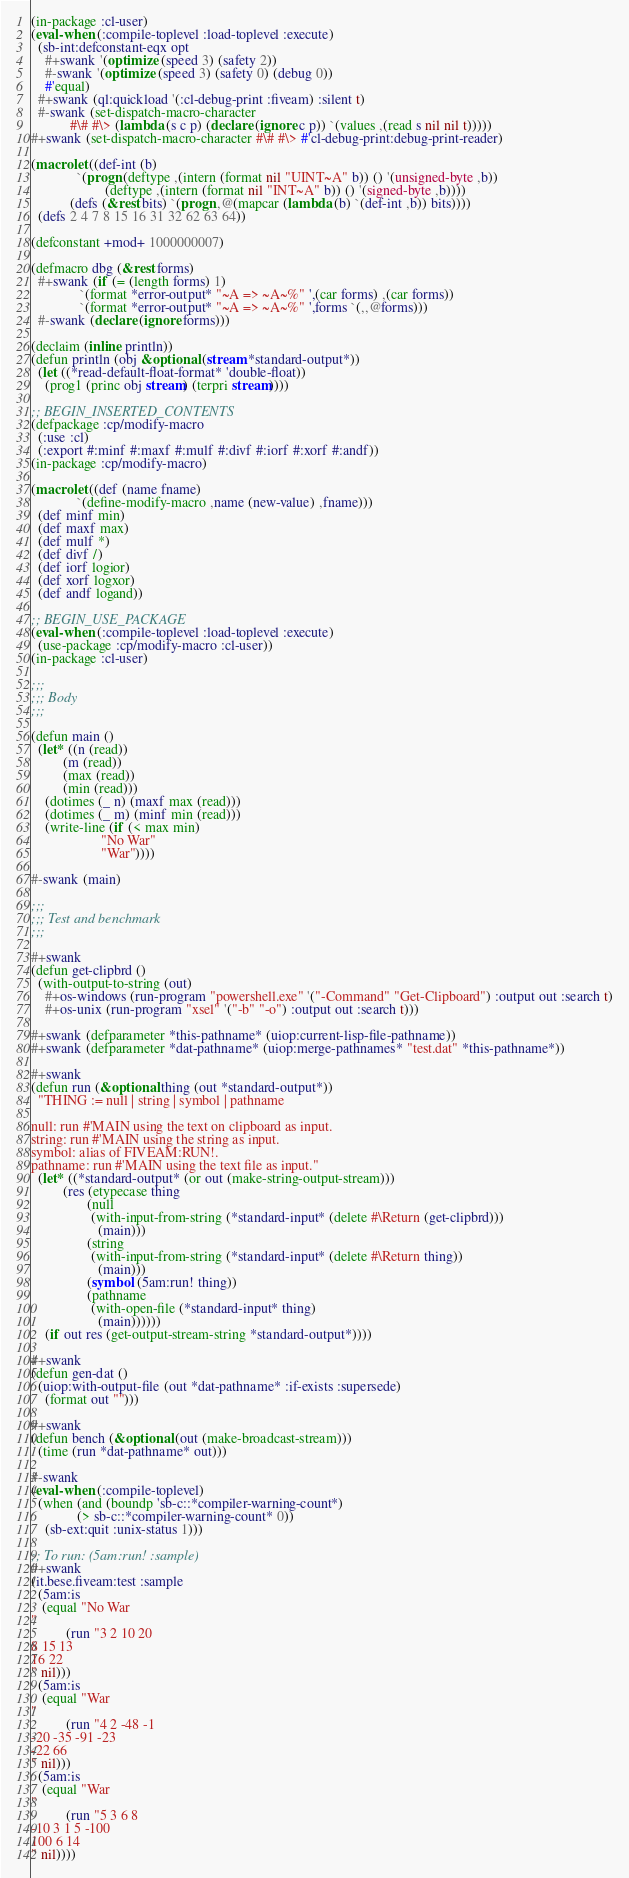<code> <loc_0><loc_0><loc_500><loc_500><_Lisp_>(in-package :cl-user)
(eval-when (:compile-toplevel :load-toplevel :execute)
  (sb-int:defconstant-eqx opt
    #+swank '(optimize (speed 3) (safety 2))
    #-swank '(optimize (speed 3) (safety 0) (debug 0))
    #'equal)
  #+swank (ql:quickload '(:cl-debug-print :fiveam) :silent t)
  #-swank (set-dispatch-macro-character
           #\# #\> (lambda (s c p) (declare (ignore c p)) `(values ,(read s nil nil t)))))
#+swank (set-dispatch-macro-character #\# #\> #'cl-debug-print:debug-print-reader)

(macrolet ((def-int (b)
             `(progn (deftype ,(intern (format nil "UINT~A" b)) () '(unsigned-byte ,b))
                     (deftype ,(intern (format nil "INT~A" b)) () '(signed-byte ,b))))
           (defs (&rest bits) `(progn ,@(mapcar (lambda (b) `(def-int ,b)) bits))))
  (defs 2 4 7 8 15 16 31 32 62 63 64))

(defconstant +mod+ 1000000007)

(defmacro dbg (&rest forms)
  #+swank (if (= (length forms) 1)
              `(format *error-output* "~A => ~A~%" ',(car forms) ,(car forms))
              `(format *error-output* "~A => ~A~%" ',forms `(,,@forms)))
  #-swank (declare (ignore forms)))

(declaim (inline println))
(defun println (obj &optional (stream *standard-output*))
  (let ((*read-default-float-format* 'double-float))
    (prog1 (princ obj stream) (terpri stream))))

;; BEGIN_INSERTED_CONTENTS
(defpackage :cp/modify-macro
  (:use :cl)
  (:export #:minf #:maxf #:mulf #:divf #:iorf #:xorf #:andf))
(in-package :cp/modify-macro)

(macrolet ((def (name fname)
             `(define-modify-macro ,name (new-value) ,fname)))
  (def minf min)
  (def maxf max)
  (def mulf *)
  (def divf /)
  (def iorf logior)
  (def xorf logxor)
  (def andf logand))

;; BEGIN_USE_PACKAGE
(eval-when (:compile-toplevel :load-toplevel :execute)
  (use-package :cp/modify-macro :cl-user))
(in-package :cl-user)

;;;
;;; Body
;;;

(defun main ()
  (let* ((n (read))
         (m (read))
         (max (read))
         (min (read)))
    (dotimes (_ n) (maxf max (read)))
    (dotimes (_ m) (minf min (read)))
    (write-line (if (< max min)
                    "No War"
                    "War"))))

#-swank (main)

;;;
;;; Test and benchmark
;;;

#+swank
(defun get-clipbrd ()
  (with-output-to-string (out)
    #+os-windows (run-program "powershell.exe" '("-Command" "Get-Clipboard") :output out :search t)
    #+os-unix (run-program "xsel" '("-b" "-o") :output out :search t)))

#+swank (defparameter *this-pathname* (uiop:current-lisp-file-pathname))
#+swank (defparameter *dat-pathname* (uiop:merge-pathnames* "test.dat" *this-pathname*))

#+swank
(defun run (&optional thing (out *standard-output*))
  "THING := null | string | symbol | pathname

null: run #'MAIN using the text on clipboard as input.
string: run #'MAIN using the string as input.
symbol: alias of FIVEAM:RUN!.
pathname: run #'MAIN using the text file as input."
  (let* ((*standard-output* (or out (make-string-output-stream)))
         (res (etypecase thing
                (null
                 (with-input-from-string (*standard-input* (delete #\Return (get-clipbrd)))
                   (main)))
                (string
                 (with-input-from-string (*standard-input* (delete #\Return thing))
                   (main)))
                (symbol (5am:run! thing))
                (pathname
                 (with-open-file (*standard-input* thing)
                   (main))))))
    (if out res (get-output-stream-string *standard-output*))))

#+swank
(defun gen-dat ()
  (uiop:with-output-file (out *dat-pathname* :if-exists :supersede)
    (format out "")))

#+swank
(defun bench (&optional (out (make-broadcast-stream)))
  (time (run *dat-pathname* out)))

#-swank
(eval-when (:compile-toplevel)
  (when (and (boundp 'sb-c::*compiler-warning-count*)
             (> sb-c::*compiler-warning-count* 0))
    (sb-ext:quit :unix-status 1)))

;; To run: (5am:run! :sample)
#+swank
(it.bese.fiveam:test :sample
  (5am:is
   (equal "No War
"
          (run "3 2 10 20
8 15 13
16 22
" nil)))
  (5am:is
   (equal "War
"
          (run "4 2 -48 -1
-20 -35 -91 -23
-22 66
" nil)))
  (5am:is
   (equal "War
"
          (run "5 3 6 8
-10 3 1 5 -100
100 6 14
" nil))))
</code> 